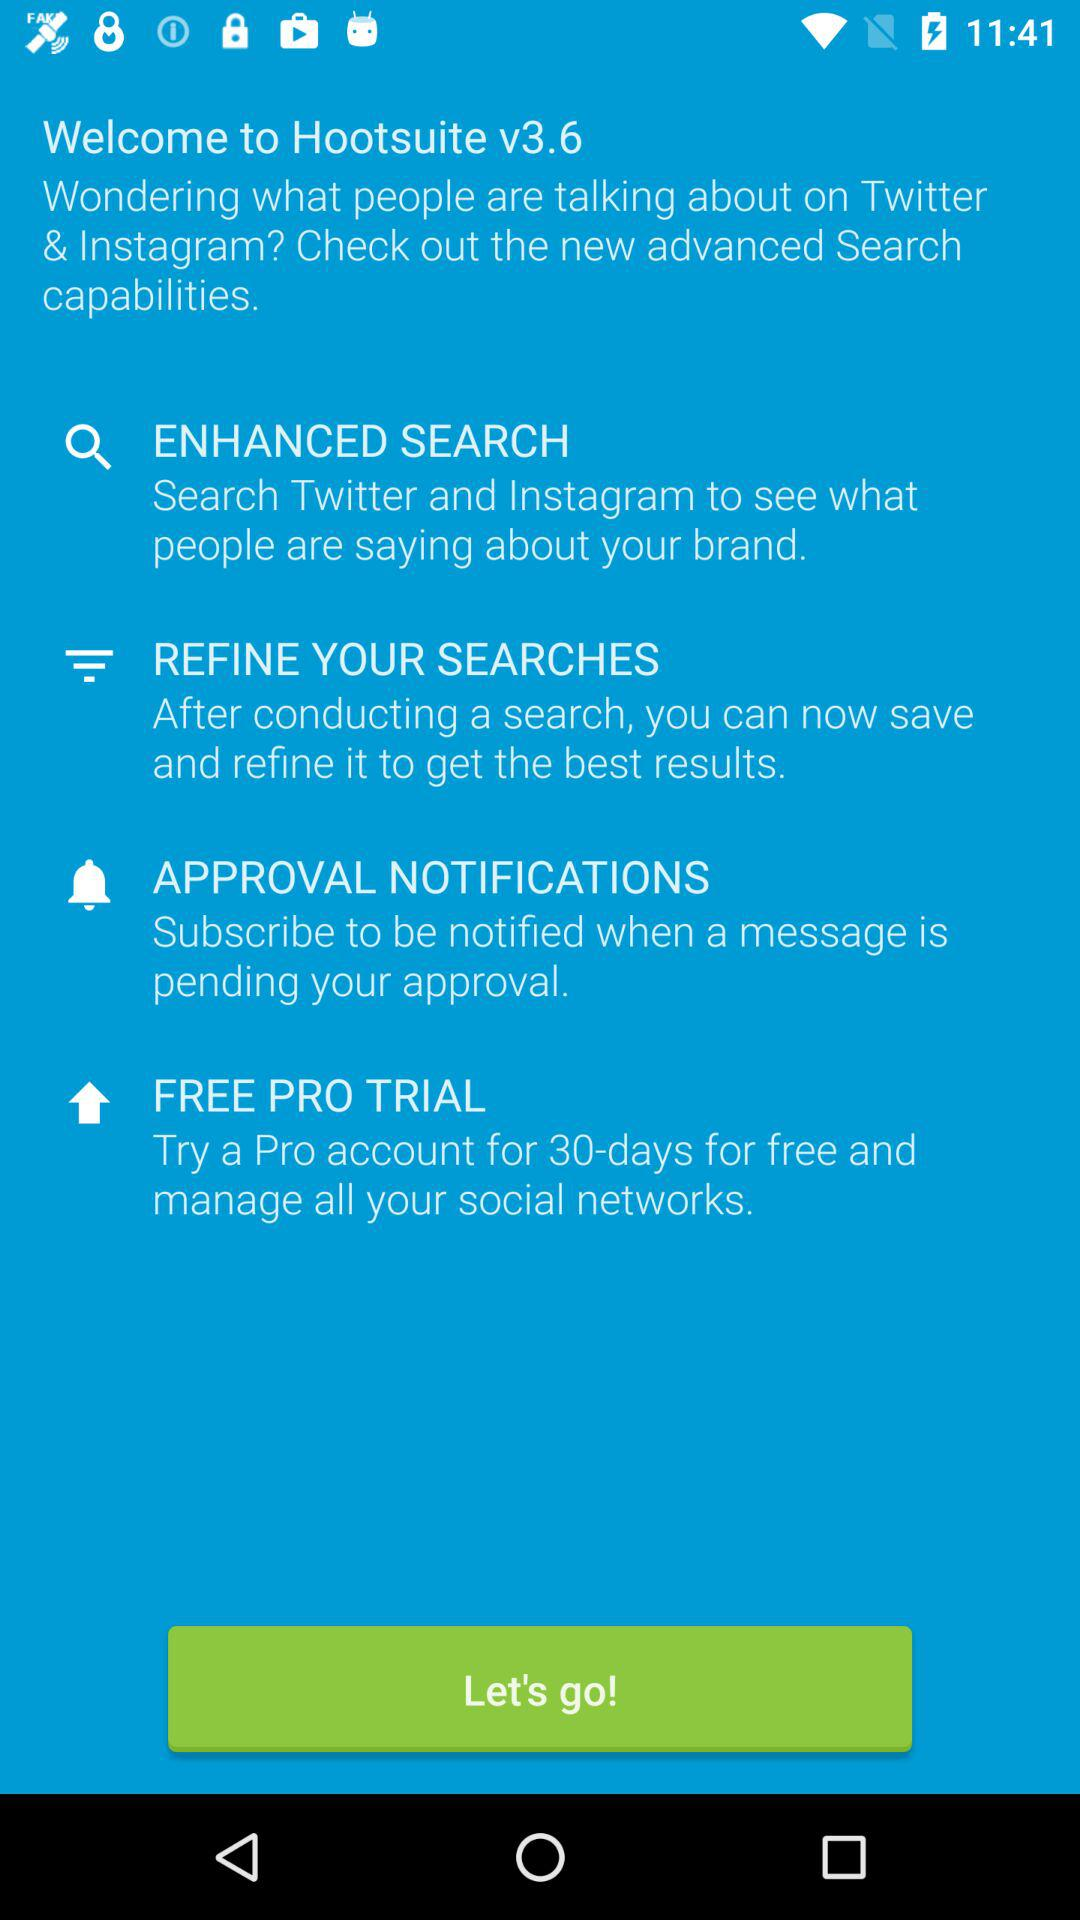How many days are shown for the free trial? There are 30 days for the free trial. 